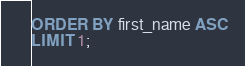Convert code to text. <code><loc_0><loc_0><loc_500><loc_500><_SQL_>ORDER BY first_name ASC
LIMIT 1;
</code> 